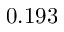<formula> <loc_0><loc_0><loc_500><loc_500>0 . 1 9 3</formula> 